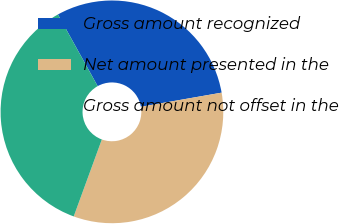Convert chart to OTSL. <chart><loc_0><loc_0><loc_500><loc_500><pie_chart><fcel>Gross amount recognized<fcel>Net amount presented in the<fcel>Gross amount not offset in the<nl><fcel>30.3%<fcel>33.33%<fcel>36.36%<nl></chart> 